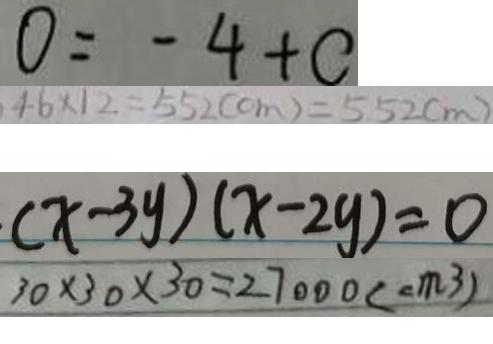Convert formula to latex. <formula><loc_0><loc_0><loc_500><loc_500>0 = - 4 + c 
 4 6 \times 1 2 = 5 5 2 ( c m ) = 5 5 2 ( m ) 
 ( x - 3 y ) ( x - 2 y ) = 0 
 3 0 \times 3 0 \times 3 0 = 2 7 0 0 0 ( c m ^ { 3 } )</formula> 